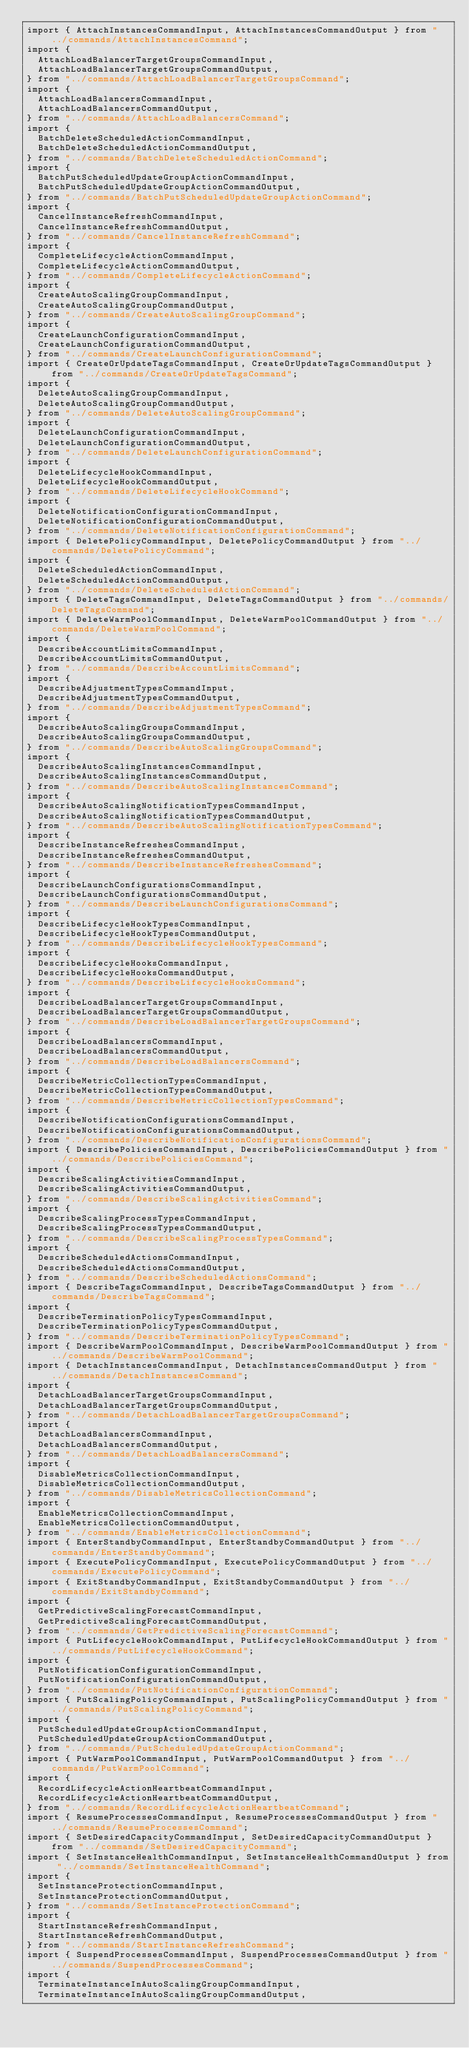Convert code to text. <code><loc_0><loc_0><loc_500><loc_500><_TypeScript_>import { AttachInstancesCommandInput, AttachInstancesCommandOutput } from "../commands/AttachInstancesCommand";
import {
  AttachLoadBalancerTargetGroupsCommandInput,
  AttachLoadBalancerTargetGroupsCommandOutput,
} from "../commands/AttachLoadBalancerTargetGroupsCommand";
import {
  AttachLoadBalancersCommandInput,
  AttachLoadBalancersCommandOutput,
} from "../commands/AttachLoadBalancersCommand";
import {
  BatchDeleteScheduledActionCommandInput,
  BatchDeleteScheduledActionCommandOutput,
} from "../commands/BatchDeleteScheduledActionCommand";
import {
  BatchPutScheduledUpdateGroupActionCommandInput,
  BatchPutScheduledUpdateGroupActionCommandOutput,
} from "../commands/BatchPutScheduledUpdateGroupActionCommand";
import {
  CancelInstanceRefreshCommandInput,
  CancelInstanceRefreshCommandOutput,
} from "../commands/CancelInstanceRefreshCommand";
import {
  CompleteLifecycleActionCommandInput,
  CompleteLifecycleActionCommandOutput,
} from "../commands/CompleteLifecycleActionCommand";
import {
  CreateAutoScalingGroupCommandInput,
  CreateAutoScalingGroupCommandOutput,
} from "../commands/CreateAutoScalingGroupCommand";
import {
  CreateLaunchConfigurationCommandInput,
  CreateLaunchConfigurationCommandOutput,
} from "../commands/CreateLaunchConfigurationCommand";
import { CreateOrUpdateTagsCommandInput, CreateOrUpdateTagsCommandOutput } from "../commands/CreateOrUpdateTagsCommand";
import {
  DeleteAutoScalingGroupCommandInput,
  DeleteAutoScalingGroupCommandOutput,
} from "../commands/DeleteAutoScalingGroupCommand";
import {
  DeleteLaunchConfigurationCommandInput,
  DeleteLaunchConfigurationCommandOutput,
} from "../commands/DeleteLaunchConfigurationCommand";
import {
  DeleteLifecycleHookCommandInput,
  DeleteLifecycleHookCommandOutput,
} from "../commands/DeleteLifecycleHookCommand";
import {
  DeleteNotificationConfigurationCommandInput,
  DeleteNotificationConfigurationCommandOutput,
} from "../commands/DeleteNotificationConfigurationCommand";
import { DeletePolicyCommandInput, DeletePolicyCommandOutput } from "../commands/DeletePolicyCommand";
import {
  DeleteScheduledActionCommandInput,
  DeleteScheduledActionCommandOutput,
} from "../commands/DeleteScheduledActionCommand";
import { DeleteTagsCommandInput, DeleteTagsCommandOutput } from "../commands/DeleteTagsCommand";
import { DeleteWarmPoolCommandInput, DeleteWarmPoolCommandOutput } from "../commands/DeleteWarmPoolCommand";
import {
  DescribeAccountLimitsCommandInput,
  DescribeAccountLimitsCommandOutput,
} from "../commands/DescribeAccountLimitsCommand";
import {
  DescribeAdjustmentTypesCommandInput,
  DescribeAdjustmentTypesCommandOutput,
} from "../commands/DescribeAdjustmentTypesCommand";
import {
  DescribeAutoScalingGroupsCommandInput,
  DescribeAutoScalingGroupsCommandOutput,
} from "../commands/DescribeAutoScalingGroupsCommand";
import {
  DescribeAutoScalingInstancesCommandInput,
  DescribeAutoScalingInstancesCommandOutput,
} from "../commands/DescribeAutoScalingInstancesCommand";
import {
  DescribeAutoScalingNotificationTypesCommandInput,
  DescribeAutoScalingNotificationTypesCommandOutput,
} from "../commands/DescribeAutoScalingNotificationTypesCommand";
import {
  DescribeInstanceRefreshesCommandInput,
  DescribeInstanceRefreshesCommandOutput,
} from "../commands/DescribeInstanceRefreshesCommand";
import {
  DescribeLaunchConfigurationsCommandInput,
  DescribeLaunchConfigurationsCommandOutput,
} from "../commands/DescribeLaunchConfigurationsCommand";
import {
  DescribeLifecycleHookTypesCommandInput,
  DescribeLifecycleHookTypesCommandOutput,
} from "../commands/DescribeLifecycleHookTypesCommand";
import {
  DescribeLifecycleHooksCommandInput,
  DescribeLifecycleHooksCommandOutput,
} from "../commands/DescribeLifecycleHooksCommand";
import {
  DescribeLoadBalancerTargetGroupsCommandInput,
  DescribeLoadBalancerTargetGroupsCommandOutput,
} from "../commands/DescribeLoadBalancerTargetGroupsCommand";
import {
  DescribeLoadBalancersCommandInput,
  DescribeLoadBalancersCommandOutput,
} from "../commands/DescribeLoadBalancersCommand";
import {
  DescribeMetricCollectionTypesCommandInput,
  DescribeMetricCollectionTypesCommandOutput,
} from "../commands/DescribeMetricCollectionTypesCommand";
import {
  DescribeNotificationConfigurationsCommandInput,
  DescribeNotificationConfigurationsCommandOutput,
} from "../commands/DescribeNotificationConfigurationsCommand";
import { DescribePoliciesCommandInput, DescribePoliciesCommandOutput } from "../commands/DescribePoliciesCommand";
import {
  DescribeScalingActivitiesCommandInput,
  DescribeScalingActivitiesCommandOutput,
} from "../commands/DescribeScalingActivitiesCommand";
import {
  DescribeScalingProcessTypesCommandInput,
  DescribeScalingProcessTypesCommandOutput,
} from "../commands/DescribeScalingProcessTypesCommand";
import {
  DescribeScheduledActionsCommandInput,
  DescribeScheduledActionsCommandOutput,
} from "../commands/DescribeScheduledActionsCommand";
import { DescribeTagsCommandInput, DescribeTagsCommandOutput } from "../commands/DescribeTagsCommand";
import {
  DescribeTerminationPolicyTypesCommandInput,
  DescribeTerminationPolicyTypesCommandOutput,
} from "../commands/DescribeTerminationPolicyTypesCommand";
import { DescribeWarmPoolCommandInput, DescribeWarmPoolCommandOutput } from "../commands/DescribeWarmPoolCommand";
import { DetachInstancesCommandInput, DetachInstancesCommandOutput } from "../commands/DetachInstancesCommand";
import {
  DetachLoadBalancerTargetGroupsCommandInput,
  DetachLoadBalancerTargetGroupsCommandOutput,
} from "../commands/DetachLoadBalancerTargetGroupsCommand";
import {
  DetachLoadBalancersCommandInput,
  DetachLoadBalancersCommandOutput,
} from "../commands/DetachLoadBalancersCommand";
import {
  DisableMetricsCollectionCommandInput,
  DisableMetricsCollectionCommandOutput,
} from "../commands/DisableMetricsCollectionCommand";
import {
  EnableMetricsCollectionCommandInput,
  EnableMetricsCollectionCommandOutput,
} from "../commands/EnableMetricsCollectionCommand";
import { EnterStandbyCommandInput, EnterStandbyCommandOutput } from "../commands/EnterStandbyCommand";
import { ExecutePolicyCommandInput, ExecutePolicyCommandOutput } from "../commands/ExecutePolicyCommand";
import { ExitStandbyCommandInput, ExitStandbyCommandOutput } from "../commands/ExitStandbyCommand";
import {
  GetPredictiveScalingForecastCommandInput,
  GetPredictiveScalingForecastCommandOutput,
} from "../commands/GetPredictiveScalingForecastCommand";
import { PutLifecycleHookCommandInput, PutLifecycleHookCommandOutput } from "../commands/PutLifecycleHookCommand";
import {
  PutNotificationConfigurationCommandInput,
  PutNotificationConfigurationCommandOutput,
} from "../commands/PutNotificationConfigurationCommand";
import { PutScalingPolicyCommandInput, PutScalingPolicyCommandOutput } from "../commands/PutScalingPolicyCommand";
import {
  PutScheduledUpdateGroupActionCommandInput,
  PutScheduledUpdateGroupActionCommandOutput,
} from "../commands/PutScheduledUpdateGroupActionCommand";
import { PutWarmPoolCommandInput, PutWarmPoolCommandOutput } from "../commands/PutWarmPoolCommand";
import {
  RecordLifecycleActionHeartbeatCommandInput,
  RecordLifecycleActionHeartbeatCommandOutput,
} from "../commands/RecordLifecycleActionHeartbeatCommand";
import { ResumeProcessesCommandInput, ResumeProcessesCommandOutput } from "../commands/ResumeProcessesCommand";
import { SetDesiredCapacityCommandInput, SetDesiredCapacityCommandOutput } from "../commands/SetDesiredCapacityCommand";
import { SetInstanceHealthCommandInput, SetInstanceHealthCommandOutput } from "../commands/SetInstanceHealthCommand";
import {
  SetInstanceProtectionCommandInput,
  SetInstanceProtectionCommandOutput,
} from "../commands/SetInstanceProtectionCommand";
import {
  StartInstanceRefreshCommandInput,
  StartInstanceRefreshCommandOutput,
} from "../commands/StartInstanceRefreshCommand";
import { SuspendProcessesCommandInput, SuspendProcessesCommandOutput } from "../commands/SuspendProcessesCommand";
import {
  TerminateInstanceInAutoScalingGroupCommandInput,
  TerminateInstanceInAutoScalingGroupCommandOutput,</code> 